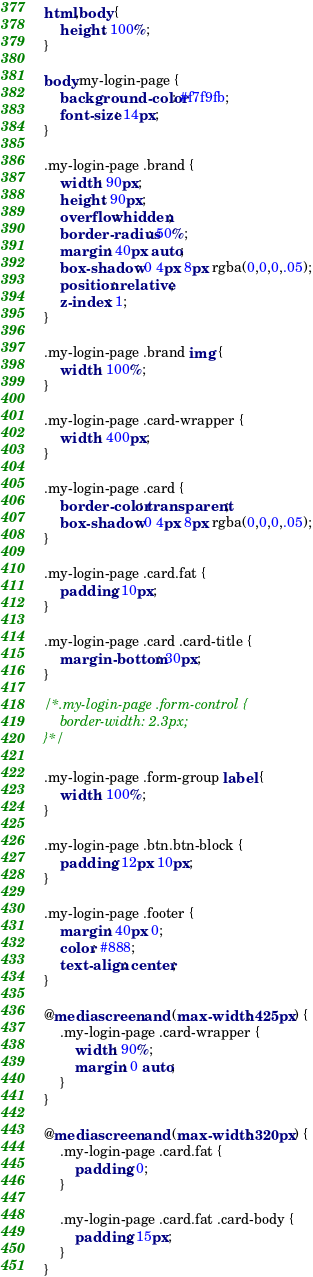Convert code to text. <code><loc_0><loc_0><loc_500><loc_500><_CSS_>html,body {
	height: 100%;
}

body.my-login-page {
	background-color: #f7f9fb;
	font-size: 14px;
}

.my-login-page .brand {
	width: 90px;
	height: 90px;
	overflow: hidden;
	border-radius: 50%;
	margin: 40px auto;
	box-shadow: 0 4px 8px rgba(0,0,0,.05);
	position: relative;
	z-index: 1;
}

.my-login-page .brand img {
	width: 100%;
}

.my-login-page .card-wrapper {
	width: 400px;
}

.my-login-page .card {
	border-color: transparent;
	box-shadow: 0 4px 8px rgba(0,0,0,.05);
}

.my-login-page .card.fat {
	padding: 10px;
}

.my-login-page .card .card-title {
	margin-bottom: 30px;
}

/*.my-login-page .form-control {
	border-width: 2.3px;
}*/

.my-login-page .form-group label {
	width: 100%;
}

.my-login-page .btn.btn-block {
	padding: 12px 10px;
}

.my-login-page .footer {
	margin: 40px 0;
	color: #888;
	text-align: center;
}

@media screen and (max-width: 425px) {
	.my-login-page .card-wrapper {
		width: 90%;
		margin: 0 auto;
	}
}

@media screen and (max-width: 320px) {
	.my-login-page .card.fat {
		padding: 0;
	}

	.my-login-page .card.fat .card-body {
		padding: 15px;
	}
}
</code> 